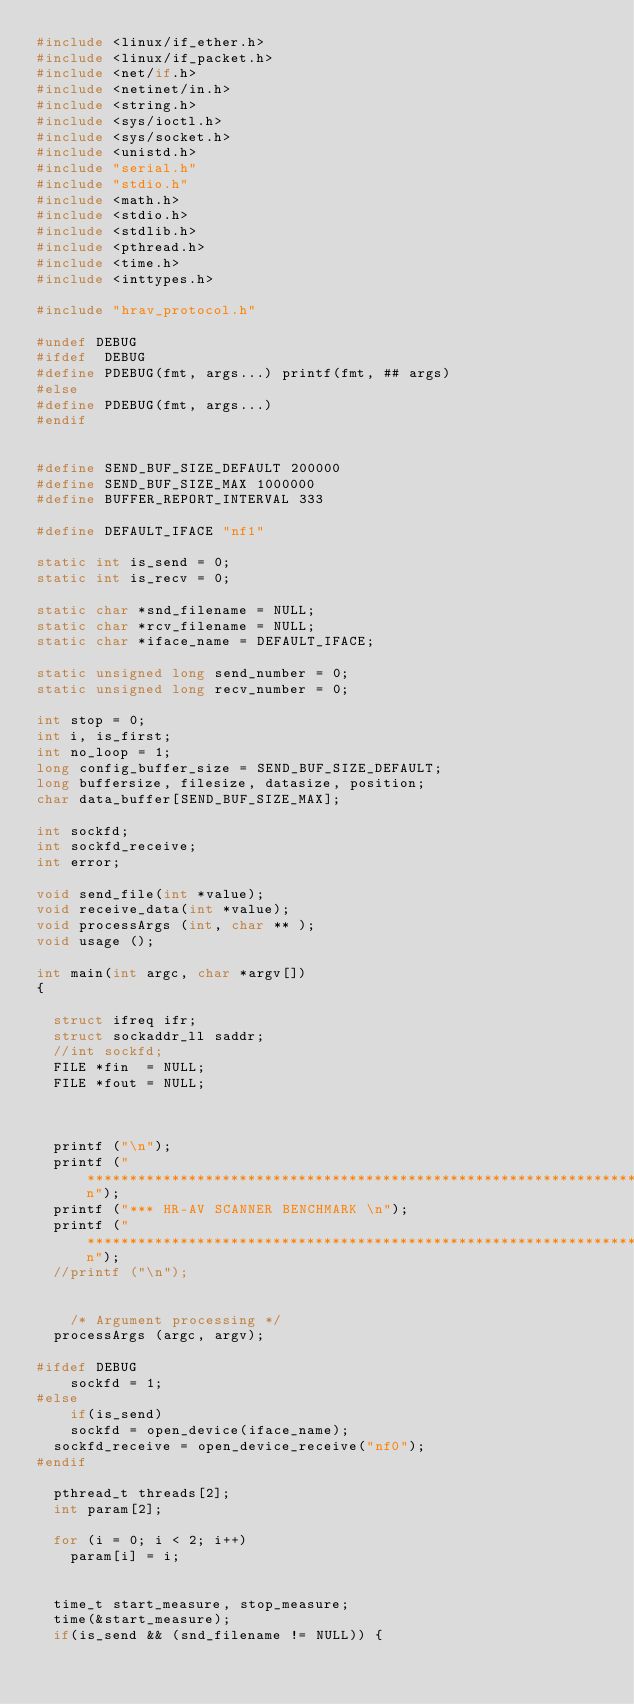<code> <loc_0><loc_0><loc_500><loc_500><_C_>#include <linux/if_ether.h>
#include <linux/if_packet.h>
#include <net/if.h>
#include <netinet/in.h>
#include <string.h>
#include <sys/ioctl.h>
#include <sys/socket.h>
#include <unistd.h>
#include "serial.h"
#include "stdio.h"
#include <math.h>
#include <stdio.h>
#include <stdlib.h>
#include <pthread.h>
#include <time.h>
#include <inttypes.h>

#include "hrav_protocol.h"

#undef DEBUG
#ifdef	DEBUG
#define PDEBUG(fmt, args...) printf(fmt, ## args)
#else
#define PDEBUG(fmt, args...)
#endif


#define SEND_BUF_SIZE_DEFAULT 200000
#define SEND_BUF_SIZE_MAX 1000000
#define BUFFER_REPORT_INTERVAL 333

#define DEFAULT_IFACE	"nf1"

static int is_send = 0;
static int is_recv = 0;

static char *snd_filename = NULL;
static char *rcv_filename = NULL;
static char *iface_name = DEFAULT_IFACE;

static unsigned long send_number = 0;
static unsigned long recv_number = 0;

int stop = 0;
int i, is_first;
int no_loop = 1;
long config_buffer_size = SEND_BUF_SIZE_DEFAULT;
long buffersize, filesize, datasize, position;
char data_buffer[SEND_BUF_SIZE_MAX];

int sockfd;
int sockfd_receive;
int error;

void send_file(int *value);
void receive_data(int *value);
void processArgs (int, char ** );
void usage ();

int main(int argc, char *argv[])
{
	
	struct ifreq ifr;
	struct sockaddr_ll saddr;
	//int sockfd;
	FILE *fin  = NULL;
	FILE *fout = NULL;
	
	

	printf ("\n");
	printf ("******************************************************************\n");
	printf ("*** HR-AV SCANNER BENCHMARK \n");
	printf ("******************************************************************\n");
	//printf ("\n");
    

    /* Argument processing */
	processArgs (argc, argv);
	
#ifdef DEBUG
    sockfd = 1;
#else
    if(is_send)
		sockfd = open_device(iface_name);
	sockfd_receive = open_device_receive("nf0");
#endif

	pthread_t threads[2];
	int param[2];

	for (i = 0; i < 2; i++) 
		param[i] = i;


	time_t start_measure, stop_measure;
	time(&start_measure);	
	if(is_send && (snd_filename != NULL)) {</code> 